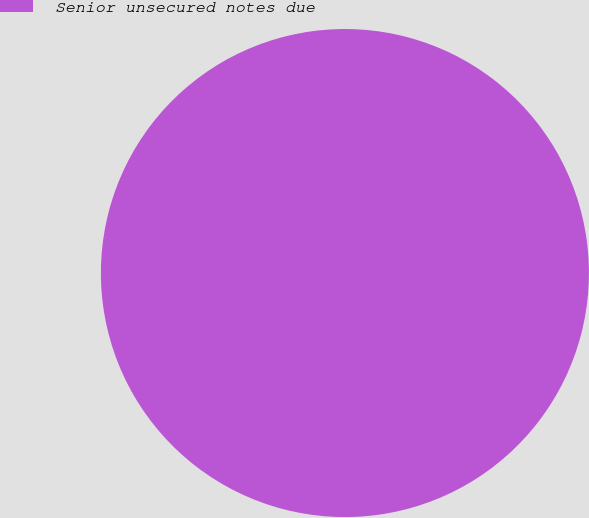Convert chart. <chart><loc_0><loc_0><loc_500><loc_500><pie_chart><fcel>Senior unsecured notes due<nl><fcel>100.0%<nl></chart> 